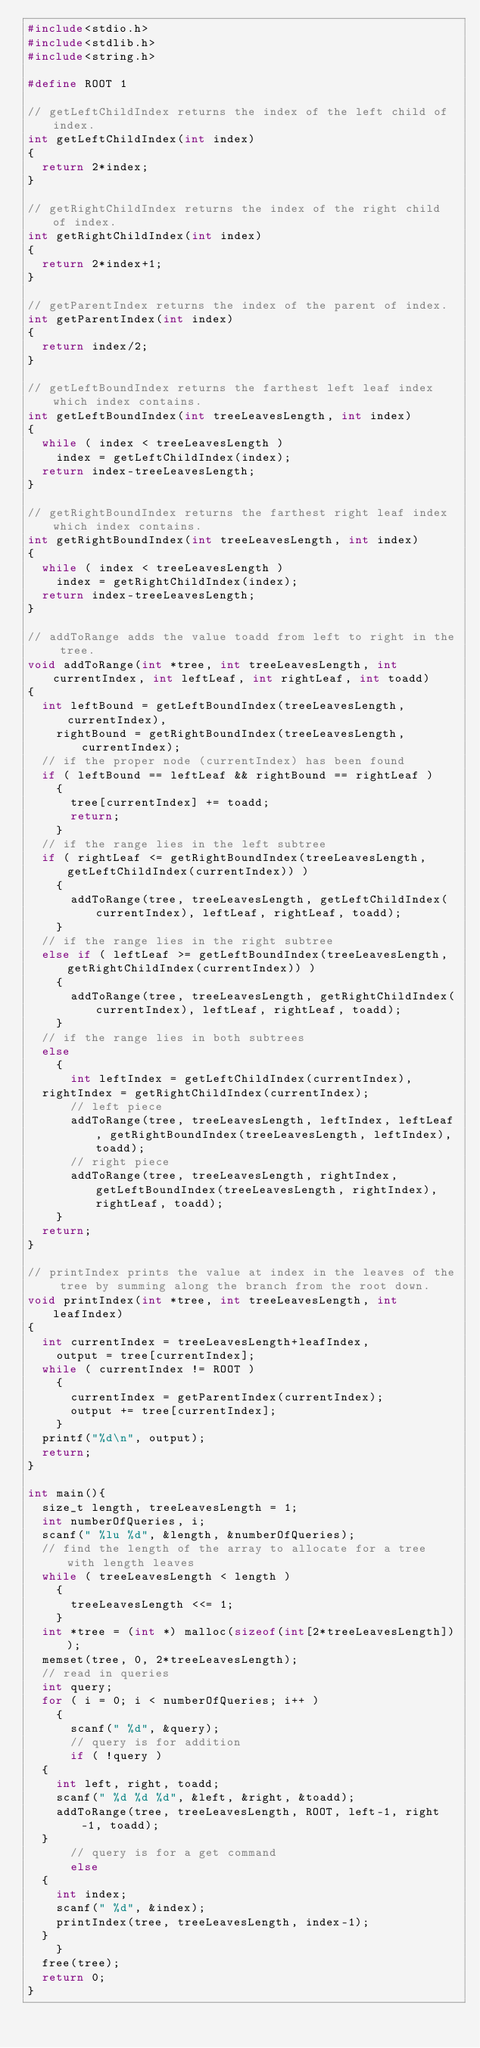<code> <loc_0><loc_0><loc_500><loc_500><_C_>#include<stdio.h>
#include<stdlib.h>
#include<string.h>

#define ROOT 1

// getLeftChildIndex returns the index of the left child of index.
int getLeftChildIndex(int index)
{
  return 2*index;
}

// getRightChildIndex returns the index of the right child of index.
int getRightChildIndex(int index)
{
  return 2*index+1;
}

// getParentIndex returns the index of the parent of index.
int getParentIndex(int index)
{
  return index/2;
}

// getLeftBoundIndex returns the farthest left leaf index which index contains.
int getLeftBoundIndex(int treeLeavesLength, int index)
{
  while ( index < treeLeavesLength )
    index = getLeftChildIndex(index);
  return index-treeLeavesLength;
}

// getRightBoundIndex returns the farthest right leaf index which index contains.
int getRightBoundIndex(int treeLeavesLength, int index)
{
  while ( index < treeLeavesLength )
    index = getRightChildIndex(index);
  return index-treeLeavesLength;
}

// addToRange adds the value toadd from left to right in the tree.
void addToRange(int *tree, int treeLeavesLength, int currentIndex, int leftLeaf, int rightLeaf, int toadd)
{
  int leftBound = getLeftBoundIndex(treeLeavesLength, currentIndex),
    rightBound = getRightBoundIndex(treeLeavesLength, currentIndex);
  // if the proper node (currentIndex) has been found
  if ( leftBound == leftLeaf && rightBound == rightLeaf )
    {
      tree[currentIndex] += toadd;
      return;
    }
  // if the range lies in the left subtree
  if ( rightLeaf <= getRightBoundIndex(treeLeavesLength, getLeftChildIndex(currentIndex)) )
    {
      addToRange(tree, treeLeavesLength, getLeftChildIndex(currentIndex), leftLeaf, rightLeaf, toadd);
    }
  // if the range lies in the right subtree
  else if ( leftLeaf >= getLeftBoundIndex(treeLeavesLength, getRightChildIndex(currentIndex)) )
    {
      addToRange(tree, treeLeavesLength, getRightChildIndex(currentIndex), leftLeaf, rightLeaf, toadd);
    }
  // if the range lies in both subtrees
  else
    {
      int leftIndex = getLeftChildIndex(currentIndex),
	rightIndex = getRightChildIndex(currentIndex);
      // left piece
      addToRange(tree, treeLeavesLength, leftIndex, leftLeaf, getRightBoundIndex(treeLeavesLength, leftIndex), toadd);
      // right piece
      addToRange(tree, treeLeavesLength, rightIndex, getLeftBoundIndex(treeLeavesLength, rightIndex), rightLeaf, toadd);
    }
  return;
}

// printIndex prints the value at index in the leaves of the tree by summing along the branch from the root down.
void printIndex(int *tree, int treeLeavesLength, int leafIndex)
{
  int currentIndex = treeLeavesLength+leafIndex,
    output = tree[currentIndex];
  while ( currentIndex != ROOT )
    {
      currentIndex = getParentIndex(currentIndex);
      output += tree[currentIndex];
    }
  printf("%d\n", output);
  return;
}

int main(){
  size_t length, treeLeavesLength = 1;
  int numberOfQueries, i;
  scanf(" %lu %d", &length, &numberOfQueries);
  // find the length of the array to allocate for a tree with length leaves
  while ( treeLeavesLength < length )
    {
      treeLeavesLength <<= 1;
    }
  int *tree = (int *) malloc(sizeof(int[2*treeLeavesLength]));
  memset(tree, 0, 2*treeLeavesLength);
  // read in queries
  int query;
  for ( i = 0; i < numberOfQueries; i++ )
    {
      scanf(" %d", &query);
      // query is for addition
      if ( !query )
	{
	  int left, right, toadd;
	  scanf(" %d %d %d", &left, &right, &toadd);
	  addToRange(tree, treeLeavesLength, ROOT, left-1, right-1, toadd);
	}
      // query is for a get command
      else
	{
	  int index;
	  scanf(" %d", &index);
	  printIndex(tree, treeLeavesLength, index-1);
	}
    }
  free(tree);
  return 0;
}

</code> 